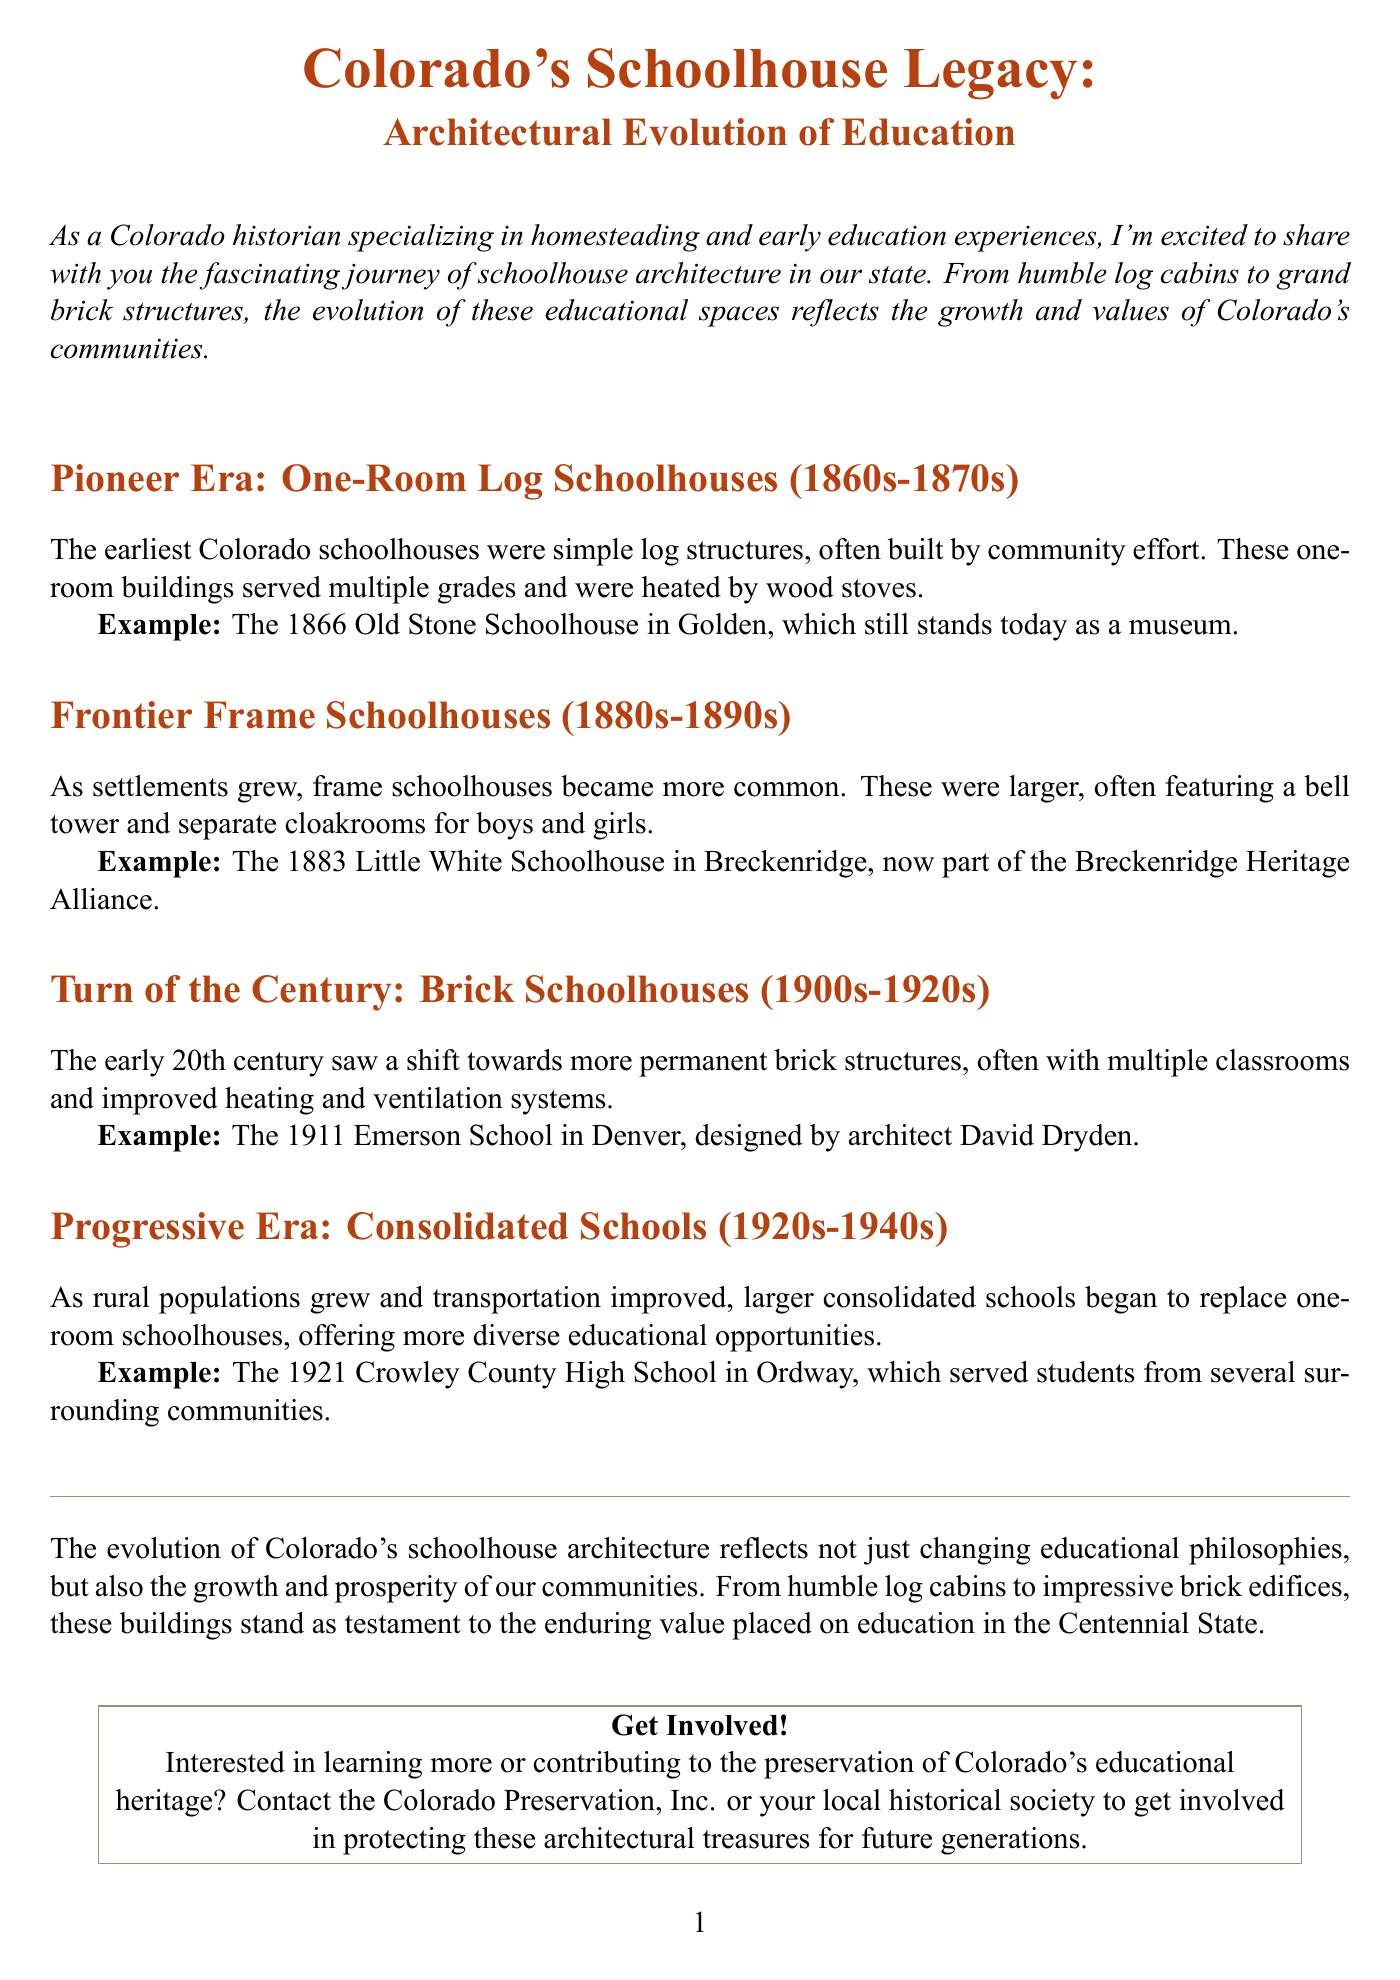what was the first type of schoolhouse in Colorado? The document states that the earliest Colorado schoolhouses were simple log structures called one-room log schoolhouses.
Answer: one-room log schoolhouses what year was the Little White Schoolhouse established? The document indicates that the Little White Schoolhouse was built in 1883.
Answer: 1883 which schoolhouse is a museum today? The document mentions the 1866 Old Stone Schoolhouse in Golden, which still stands today as a museum.
Answer: 1866 Old Stone Schoolhouse what architectural feature became common in frame schoolhouses? The document states that frame schoolhouses often featured a bell tower.
Answer: bell tower in what year was the Emerson School in Denver designed? According to the document, the Emerson School was designed in 1911.
Answer: 1911 which period saw the transition to brick schoolhouses? The document highlights that the transition to more permanent brick structures occurred in the early 20th century, from 1900s to 1920s.
Answer: early 20th century how did rural population changes affect schoolhouse architecture? The document explains that as rural populations grew and transportation improved, larger consolidated schools began to replace one-room schoolhouses.
Answer: larger consolidated schools who authored the newsletter? The document identifies the author as Dr. Emily Sanderson.
Answer: Dr. Emily Sanderson what type of schools replaced one-room schoolhouses in the Progressive Era? The document states that consolidated schools began to replace one-room schoolhouses during this era.
Answer: consolidated schools 